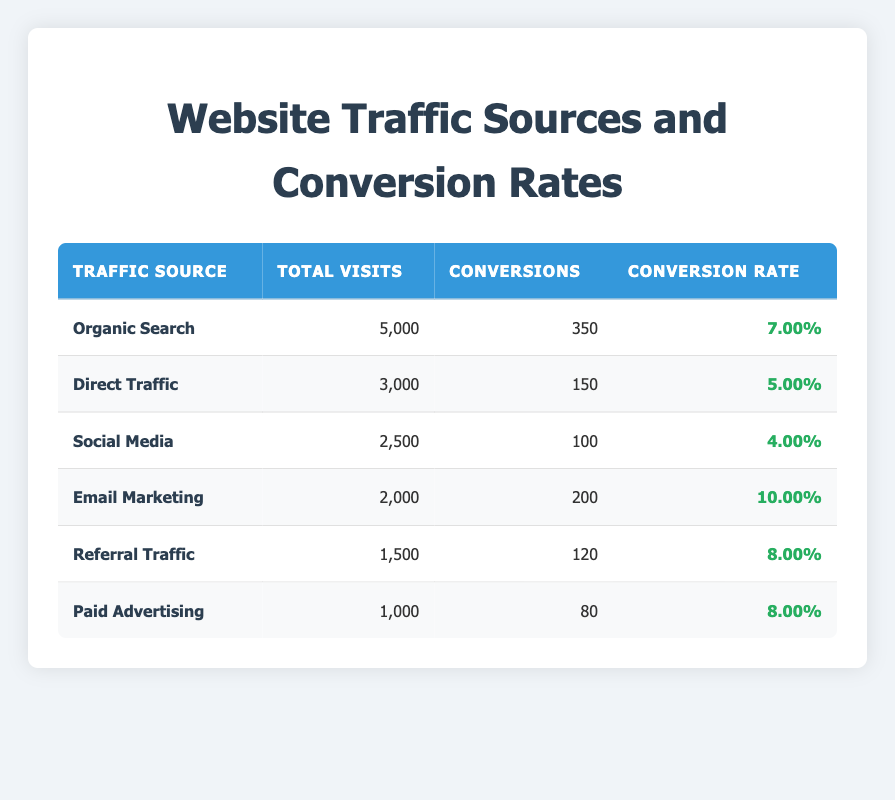What is the conversion rate for Email Marketing? The table shows that Email Marketing has 200 conversions from 2,000 total visits. The conversion rate can be calculated as (200 / 2000) * 100% = 10%.
Answer: 10.00% Which traffic source has the highest total visits? The table lists the total visits for each traffic source. Organic Search has the highest total visits with 5,000.
Answer: Organic Search Is the conversion rate from Organic Search higher than that from Social Media? Organic Search has a conversion rate of 7.00%, while Social Media has a rate of 4.00%. Since 7.00% > 4.00%, the statement is true.
Answer: Yes What is the total number of conversions from all traffic sources combined? To find the total conversions, we sum the conversions from all sources: 350 + 150 + 100 + 200 + 120 + 80 = 1,000.
Answer: 1,000 Which traffic source has the lowest conversion rate? The table shows that Paid Advertising has a conversion rate of 8.00%, while Social Media has a rate of 4.00%. Comparing these, Social Media has the lowest conversion rate.
Answer: Social Media What is the conversion rate for Direct Traffic? Direct Traffic has 150 conversions from a total of 3,000 visits. The conversion rate is (150 / 3000) * 100% = 5.00%.
Answer: 5.00% How many more conversions does Email Marketing have than Social Media? Email Marketing has 200 conversions and Social Media has 100 conversions. The difference is 200 - 100 = 100.
Answer: 100 Which source generated twice as many visits compared to Paid Advertising? Paid Advertising has 1,000 visits. The source that generated twice as many visits would require 2,000 visits. Looking at the table, Email Marketing has exactly 2,000 visits, so it fits the criteria.
Answer: Email Marketing What is the average conversion rate across all traffic sources? First, we need to calculate each source's conversion rate: Organic Search (7.00%), Direct Traffic (5.00%), Social Media (4.00%), Email Marketing (10.00%), Referral Traffic (8.00%), Paid Advertising (8.00%). Then we find the average: (7.00% + 5.00% + 4.00% + 10.00% + 8.00% + 8.00%)/6 = 6.33%.
Answer: 6.33% 